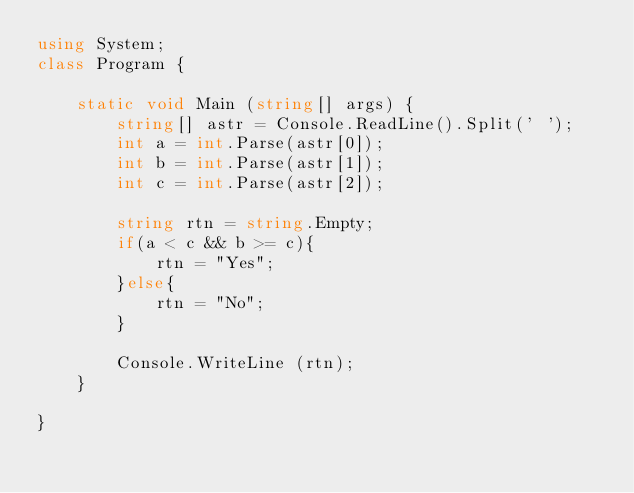Convert code to text. <code><loc_0><loc_0><loc_500><loc_500><_C#_>using System;
class Program {

    static void Main (string[] args) {
        string[] astr = Console.ReadLine().Split(' ');
        int a = int.Parse(astr[0]);
        int b = int.Parse(astr[1]);
        int c = int.Parse(astr[2]);

        string rtn = string.Empty;
        if(a < c && b >= c){
            rtn = "Yes";
        }else{
            rtn = "No";
        }

        Console.WriteLine (rtn);
    }

}</code> 